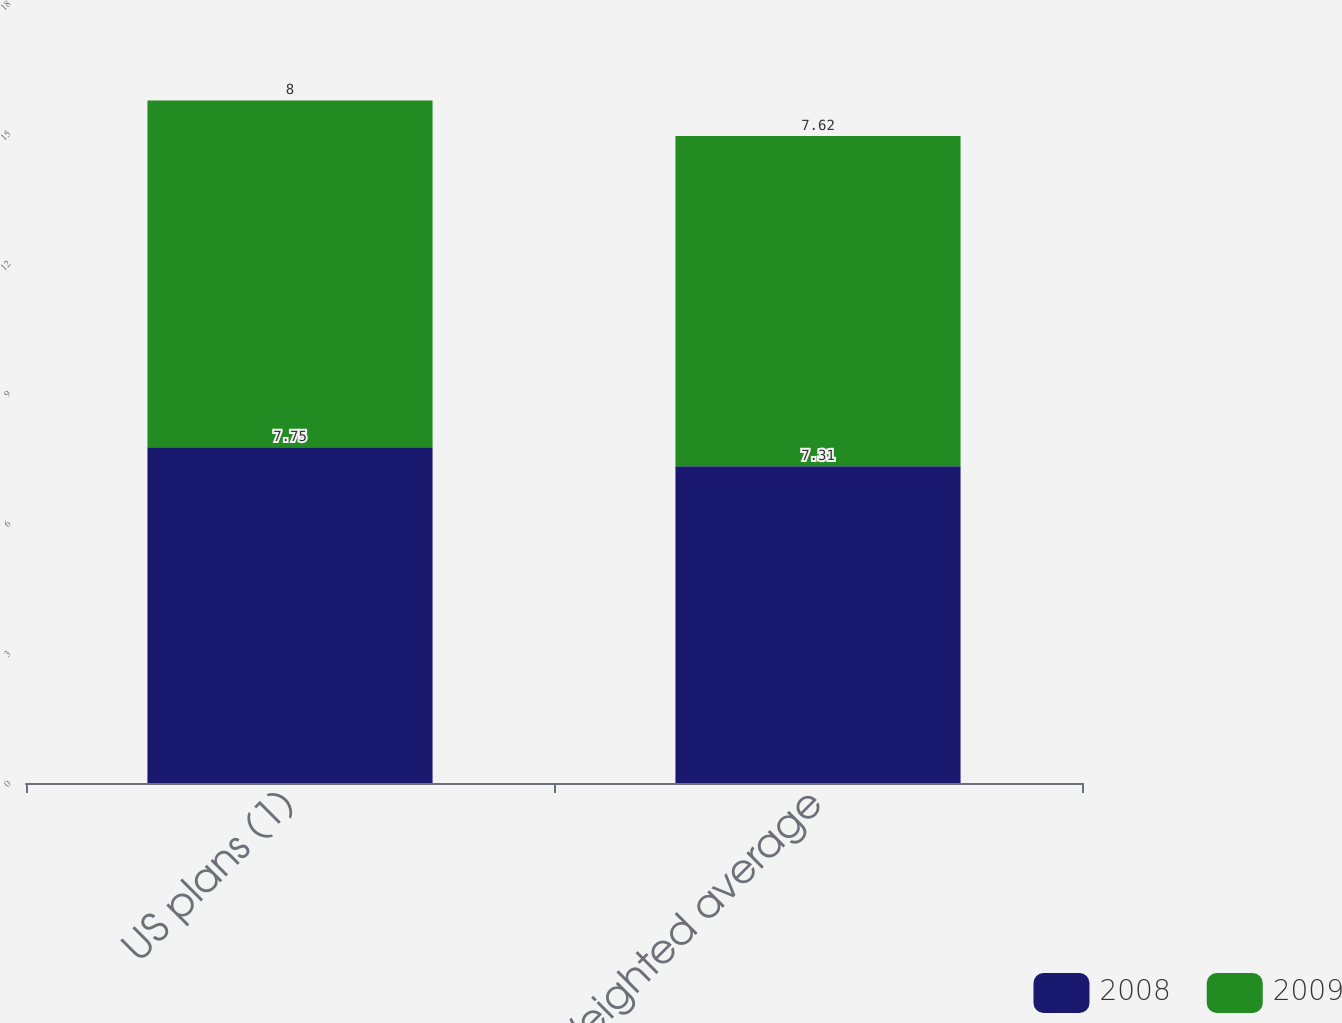Convert chart. <chart><loc_0><loc_0><loc_500><loc_500><stacked_bar_chart><ecel><fcel>US plans (1)<fcel>Weighted average<nl><fcel>2008<fcel>7.75<fcel>7.31<nl><fcel>2009<fcel>8<fcel>7.62<nl></chart> 